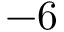<formula> <loc_0><loc_0><loc_500><loc_500>- 6</formula> 